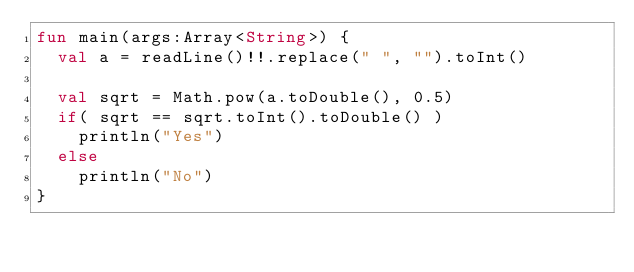<code> <loc_0><loc_0><loc_500><loc_500><_Kotlin_>fun main(args:Array<String>) {
  val a = readLine()!!.replace(" ", "").toInt()

  val sqrt = Math.pow(a.toDouble(), 0.5)
  if( sqrt == sqrt.toInt().toDouble() )
    println("Yes")
  else
    println("No")
}</code> 